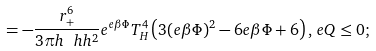<formula> <loc_0><loc_0><loc_500><loc_500>\, = - \frac { r _ { + } ^ { 6 } } { 3 \pi h \ h h ^ { 2 } } e ^ { e \beta \Phi } T _ { H } ^ { 4 } \left ( 3 ( e \beta \Phi ) ^ { 2 } - 6 e \beta \Phi + 6 \right ) , \, e Q \leq 0 ;</formula> 